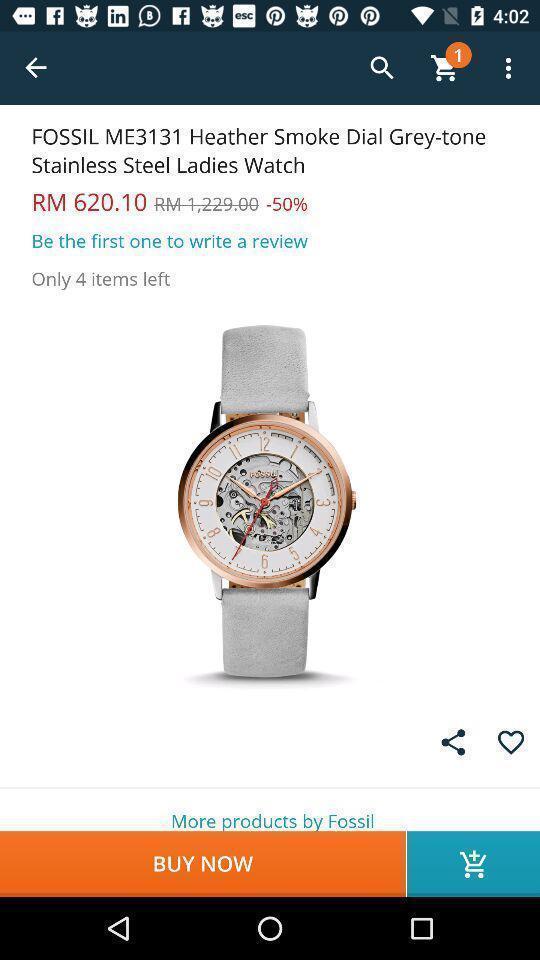Describe the visual elements of this screenshot. Screen page of shopping app. 